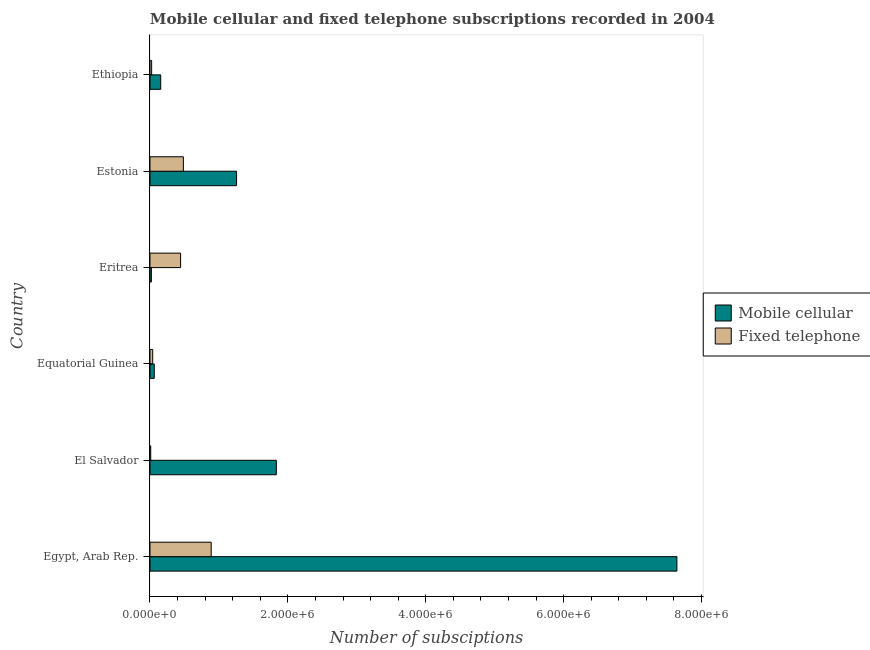How many different coloured bars are there?
Provide a succinct answer. 2. How many groups of bars are there?
Provide a short and direct response. 6. Are the number of bars per tick equal to the number of legend labels?
Ensure brevity in your answer.  Yes. Are the number of bars on each tick of the Y-axis equal?
Provide a succinct answer. Yes. How many bars are there on the 4th tick from the top?
Provide a succinct answer. 2. How many bars are there on the 6th tick from the bottom?
Keep it short and to the point. 2. What is the label of the 1st group of bars from the top?
Your response must be concise. Ethiopia. What is the number of mobile cellular subscriptions in Estonia?
Offer a very short reply. 1.26e+06. Across all countries, what is the maximum number of fixed telephone subscriptions?
Your answer should be compact. 8.88e+05. Across all countries, what is the minimum number of fixed telephone subscriptions?
Your answer should be very brief. 1.05e+04. In which country was the number of fixed telephone subscriptions maximum?
Your response must be concise. Egypt, Arab Rep. In which country was the number of mobile cellular subscriptions minimum?
Make the answer very short. Eritrea. What is the total number of fixed telephone subscriptions in the graph?
Make the answer very short. 1.89e+06. What is the difference between the number of fixed telephone subscriptions in Eritrea and that in Estonia?
Provide a succinct answer. -4.03e+04. What is the difference between the number of fixed telephone subscriptions in Estonia and the number of mobile cellular subscriptions in Egypt, Arab Rep.?
Give a very brief answer. -7.16e+06. What is the average number of mobile cellular subscriptions per country?
Offer a terse response. 1.83e+06. What is the difference between the number of fixed telephone subscriptions and number of mobile cellular subscriptions in Estonia?
Offer a very short reply. -7.71e+05. In how many countries, is the number of fixed telephone subscriptions greater than 5200000 ?
Your response must be concise. 0. What is the ratio of the number of mobile cellular subscriptions in Estonia to that in Ethiopia?
Your answer should be compact. 8.07. What is the difference between the highest and the second highest number of fixed telephone subscriptions?
Give a very brief answer. 4.03e+05. What is the difference between the highest and the lowest number of fixed telephone subscriptions?
Give a very brief answer. 8.77e+05. Is the sum of the number of fixed telephone subscriptions in El Salvador and Estonia greater than the maximum number of mobile cellular subscriptions across all countries?
Your response must be concise. No. What does the 2nd bar from the top in Ethiopia represents?
Provide a short and direct response. Mobile cellular. What does the 2nd bar from the bottom in Egypt, Arab Rep. represents?
Make the answer very short. Fixed telephone. How many bars are there?
Your answer should be very brief. 12. Are all the bars in the graph horizontal?
Keep it short and to the point. Yes. How many countries are there in the graph?
Give a very brief answer. 6. Where does the legend appear in the graph?
Your response must be concise. Center right. How many legend labels are there?
Your response must be concise. 2. What is the title of the graph?
Provide a short and direct response. Mobile cellular and fixed telephone subscriptions recorded in 2004. What is the label or title of the X-axis?
Make the answer very short. Number of subsciptions. What is the label or title of the Y-axis?
Provide a short and direct response. Country. What is the Number of subsciptions in Mobile cellular in Egypt, Arab Rep.?
Your answer should be compact. 7.64e+06. What is the Number of subsciptions of Fixed telephone in Egypt, Arab Rep.?
Make the answer very short. 8.88e+05. What is the Number of subsciptions of Mobile cellular in El Salvador?
Your response must be concise. 1.83e+06. What is the Number of subsciptions in Fixed telephone in El Salvador?
Offer a very short reply. 1.05e+04. What is the Number of subsciptions in Mobile cellular in Equatorial Guinea?
Ensure brevity in your answer.  6.19e+04. What is the Number of subsciptions in Fixed telephone in Equatorial Guinea?
Your answer should be compact. 3.93e+04. What is the Number of subsciptions in Fixed telephone in Eritrea?
Your answer should be very brief. 4.44e+05. What is the Number of subsciptions in Mobile cellular in Estonia?
Keep it short and to the point. 1.26e+06. What is the Number of subsciptions of Fixed telephone in Estonia?
Provide a short and direct response. 4.84e+05. What is the Number of subsciptions of Mobile cellular in Ethiopia?
Your answer should be compact. 1.56e+05. What is the Number of subsciptions of Fixed telephone in Ethiopia?
Provide a short and direct response. 2.40e+04. Across all countries, what is the maximum Number of subsciptions of Mobile cellular?
Provide a succinct answer. 7.64e+06. Across all countries, what is the maximum Number of subsciptions in Fixed telephone?
Your response must be concise. 8.88e+05. Across all countries, what is the minimum Number of subsciptions in Mobile cellular?
Give a very brief answer. 2.00e+04. Across all countries, what is the minimum Number of subsciptions in Fixed telephone?
Your answer should be compact. 1.05e+04. What is the total Number of subsciptions of Mobile cellular in the graph?
Make the answer very short. 1.10e+07. What is the total Number of subsciptions of Fixed telephone in the graph?
Give a very brief answer. 1.89e+06. What is the difference between the Number of subsciptions in Mobile cellular in Egypt, Arab Rep. and that in El Salvador?
Give a very brief answer. 5.81e+06. What is the difference between the Number of subsciptions in Fixed telephone in Egypt, Arab Rep. and that in El Salvador?
Offer a terse response. 8.77e+05. What is the difference between the Number of subsciptions of Mobile cellular in Egypt, Arab Rep. and that in Equatorial Guinea?
Your response must be concise. 7.58e+06. What is the difference between the Number of subsciptions of Fixed telephone in Egypt, Arab Rep. and that in Equatorial Guinea?
Ensure brevity in your answer.  8.49e+05. What is the difference between the Number of subsciptions in Mobile cellular in Egypt, Arab Rep. and that in Eritrea?
Keep it short and to the point. 7.62e+06. What is the difference between the Number of subsciptions in Fixed telephone in Egypt, Arab Rep. and that in Eritrea?
Provide a succinct answer. 4.44e+05. What is the difference between the Number of subsciptions in Mobile cellular in Egypt, Arab Rep. and that in Estonia?
Keep it short and to the point. 6.39e+06. What is the difference between the Number of subsciptions of Fixed telephone in Egypt, Arab Rep. and that in Estonia?
Your response must be concise. 4.03e+05. What is the difference between the Number of subsciptions in Mobile cellular in Egypt, Arab Rep. and that in Ethiopia?
Keep it short and to the point. 7.49e+06. What is the difference between the Number of subsciptions in Fixed telephone in Egypt, Arab Rep. and that in Ethiopia?
Provide a short and direct response. 8.64e+05. What is the difference between the Number of subsciptions of Mobile cellular in El Salvador and that in Equatorial Guinea?
Your answer should be very brief. 1.77e+06. What is the difference between the Number of subsciptions of Fixed telephone in El Salvador and that in Equatorial Guinea?
Make the answer very short. -2.88e+04. What is the difference between the Number of subsciptions of Mobile cellular in El Salvador and that in Eritrea?
Offer a terse response. 1.81e+06. What is the difference between the Number of subsciptions in Fixed telephone in El Salvador and that in Eritrea?
Your answer should be compact. -4.34e+05. What is the difference between the Number of subsciptions of Mobile cellular in El Salvador and that in Estonia?
Make the answer very short. 5.77e+05. What is the difference between the Number of subsciptions of Fixed telephone in El Salvador and that in Estonia?
Ensure brevity in your answer.  -4.74e+05. What is the difference between the Number of subsciptions of Mobile cellular in El Salvador and that in Ethiopia?
Give a very brief answer. 1.68e+06. What is the difference between the Number of subsciptions of Fixed telephone in El Salvador and that in Ethiopia?
Offer a terse response. -1.35e+04. What is the difference between the Number of subsciptions of Mobile cellular in Equatorial Guinea and that in Eritrea?
Your answer should be very brief. 4.19e+04. What is the difference between the Number of subsciptions of Fixed telephone in Equatorial Guinea and that in Eritrea?
Offer a terse response. -4.05e+05. What is the difference between the Number of subsciptions in Mobile cellular in Equatorial Guinea and that in Estonia?
Your answer should be very brief. -1.19e+06. What is the difference between the Number of subsciptions of Fixed telephone in Equatorial Guinea and that in Estonia?
Offer a terse response. -4.45e+05. What is the difference between the Number of subsciptions of Mobile cellular in Equatorial Guinea and that in Ethiopia?
Ensure brevity in your answer.  -9.36e+04. What is the difference between the Number of subsciptions of Fixed telephone in Equatorial Guinea and that in Ethiopia?
Provide a short and direct response. 1.53e+04. What is the difference between the Number of subsciptions in Mobile cellular in Eritrea and that in Estonia?
Your answer should be compact. -1.24e+06. What is the difference between the Number of subsciptions in Fixed telephone in Eritrea and that in Estonia?
Make the answer very short. -4.03e+04. What is the difference between the Number of subsciptions in Mobile cellular in Eritrea and that in Ethiopia?
Your answer should be compact. -1.36e+05. What is the difference between the Number of subsciptions of Fixed telephone in Eritrea and that in Ethiopia?
Your answer should be compact. 4.20e+05. What is the difference between the Number of subsciptions in Mobile cellular in Estonia and that in Ethiopia?
Give a very brief answer. 1.10e+06. What is the difference between the Number of subsciptions of Fixed telephone in Estonia and that in Ethiopia?
Your answer should be very brief. 4.60e+05. What is the difference between the Number of subsciptions in Mobile cellular in Egypt, Arab Rep. and the Number of subsciptions in Fixed telephone in El Salvador?
Keep it short and to the point. 7.63e+06. What is the difference between the Number of subsciptions of Mobile cellular in Egypt, Arab Rep. and the Number of subsciptions of Fixed telephone in Equatorial Guinea?
Provide a short and direct response. 7.60e+06. What is the difference between the Number of subsciptions in Mobile cellular in Egypt, Arab Rep. and the Number of subsciptions in Fixed telephone in Eritrea?
Offer a terse response. 7.20e+06. What is the difference between the Number of subsciptions of Mobile cellular in Egypt, Arab Rep. and the Number of subsciptions of Fixed telephone in Estonia?
Your answer should be very brief. 7.16e+06. What is the difference between the Number of subsciptions of Mobile cellular in Egypt, Arab Rep. and the Number of subsciptions of Fixed telephone in Ethiopia?
Provide a short and direct response. 7.62e+06. What is the difference between the Number of subsciptions of Mobile cellular in El Salvador and the Number of subsciptions of Fixed telephone in Equatorial Guinea?
Keep it short and to the point. 1.79e+06. What is the difference between the Number of subsciptions in Mobile cellular in El Salvador and the Number of subsciptions in Fixed telephone in Eritrea?
Your answer should be very brief. 1.39e+06. What is the difference between the Number of subsciptions in Mobile cellular in El Salvador and the Number of subsciptions in Fixed telephone in Estonia?
Offer a very short reply. 1.35e+06. What is the difference between the Number of subsciptions in Mobile cellular in El Salvador and the Number of subsciptions in Fixed telephone in Ethiopia?
Your answer should be compact. 1.81e+06. What is the difference between the Number of subsciptions in Mobile cellular in Equatorial Guinea and the Number of subsciptions in Fixed telephone in Eritrea?
Provide a short and direct response. -3.82e+05. What is the difference between the Number of subsciptions in Mobile cellular in Equatorial Guinea and the Number of subsciptions in Fixed telephone in Estonia?
Your answer should be very brief. -4.22e+05. What is the difference between the Number of subsciptions in Mobile cellular in Equatorial Guinea and the Number of subsciptions in Fixed telephone in Ethiopia?
Keep it short and to the point. 3.79e+04. What is the difference between the Number of subsciptions of Mobile cellular in Eritrea and the Number of subsciptions of Fixed telephone in Estonia?
Your answer should be very brief. -4.64e+05. What is the difference between the Number of subsciptions in Mobile cellular in Eritrea and the Number of subsciptions in Fixed telephone in Ethiopia?
Give a very brief answer. -3958. What is the difference between the Number of subsciptions of Mobile cellular in Estonia and the Number of subsciptions of Fixed telephone in Ethiopia?
Your answer should be compact. 1.23e+06. What is the average Number of subsciptions of Mobile cellular per country?
Your answer should be very brief. 1.83e+06. What is the average Number of subsciptions of Fixed telephone per country?
Your answer should be compact. 3.15e+05. What is the difference between the Number of subsciptions in Mobile cellular and Number of subsciptions in Fixed telephone in Egypt, Arab Rep.?
Your answer should be compact. 6.76e+06. What is the difference between the Number of subsciptions in Mobile cellular and Number of subsciptions in Fixed telephone in El Salvador?
Your answer should be very brief. 1.82e+06. What is the difference between the Number of subsciptions in Mobile cellular and Number of subsciptions in Fixed telephone in Equatorial Guinea?
Ensure brevity in your answer.  2.26e+04. What is the difference between the Number of subsciptions of Mobile cellular and Number of subsciptions of Fixed telephone in Eritrea?
Offer a terse response. -4.24e+05. What is the difference between the Number of subsciptions in Mobile cellular and Number of subsciptions in Fixed telephone in Estonia?
Provide a short and direct response. 7.71e+05. What is the difference between the Number of subsciptions in Mobile cellular and Number of subsciptions in Fixed telephone in Ethiopia?
Offer a very short reply. 1.32e+05. What is the ratio of the Number of subsciptions of Mobile cellular in Egypt, Arab Rep. to that in El Salvador?
Give a very brief answer. 4.17. What is the ratio of the Number of subsciptions in Fixed telephone in Egypt, Arab Rep. to that in El Salvador?
Your answer should be very brief. 84.55. What is the ratio of the Number of subsciptions in Mobile cellular in Egypt, Arab Rep. to that in Equatorial Guinea?
Offer a terse response. 123.47. What is the ratio of the Number of subsciptions in Fixed telephone in Egypt, Arab Rep. to that in Equatorial Guinea?
Keep it short and to the point. 22.61. What is the ratio of the Number of subsciptions of Mobile cellular in Egypt, Arab Rep. to that in Eritrea?
Keep it short and to the point. 382.15. What is the ratio of the Number of subsciptions of Fixed telephone in Egypt, Arab Rep. to that in Eritrea?
Make the answer very short. 2. What is the ratio of the Number of subsciptions of Mobile cellular in Egypt, Arab Rep. to that in Estonia?
Ensure brevity in your answer.  6.09. What is the ratio of the Number of subsciptions of Fixed telephone in Egypt, Arab Rep. to that in Estonia?
Provide a succinct answer. 1.83. What is the ratio of the Number of subsciptions in Mobile cellular in Egypt, Arab Rep. to that in Ethiopia?
Your answer should be compact. 49.14. What is the ratio of the Number of subsciptions of Fixed telephone in Egypt, Arab Rep. to that in Ethiopia?
Your answer should be very brief. 37.06. What is the ratio of the Number of subsciptions in Mobile cellular in El Salvador to that in Equatorial Guinea?
Provide a succinct answer. 29.61. What is the ratio of the Number of subsciptions of Fixed telephone in El Salvador to that in Equatorial Guinea?
Make the answer very short. 0.27. What is the ratio of the Number of subsciptions of Mobile cellular in El Salvador to that in Eritrea?
Your answer should be very brief. 91.63. What is the ratio of the Number of subsciptions of Fixed telephone in El Salvador to that in Eritrea?
Provide a short and direct response. 0.02. What is the ratio of the Number of subsciptions of Mobile cellular in El Salvador to that in Estonia?
Give a very brief answer. 1.46. What is the ratio of the Number of subsciptions in Fixed telephone in El Salvador to that in Estonia?
Provide a short and direct response. 0.02. What is the ratio of the Number of subsciptions of Mobile cellular in El Salvador to that in Ethiopia?
Offer a very short reply. 11.78. What is the ratio of the Number of subsciptions in Fixed telephone in El Salvador to that in Ethiopia?
Offer a very short reply. 0.44. What is the ratio of the Number of subsciptions in Mobile cellular in Equatorial Guinea to that in Eritrea?
Make the answer very short. 3.1. What is the ratio of the Number of subsciptions of Fixed telephone in Equatorial Guinea to that in Eritrea?
Provide a short and direct response. 0.09. What is the ratio of the Number of subsciptions in Mobile cellular in Equatorial Guinea to that in Estonia?
Your answer should be very brief. 0.05. What is the ratio of the Number of subsciptions in Fixed telephone in Equatorial Guinea to that in Estonia?
Ensure brevity in your answer.  0.08. What is the ratio of the Number of subsciptions of Mobile cellular in Equatorial Guinea to that in Ethiopia?
Make the answer very short. 0.4. What is the ratio of the Number of subsciptions of Fixed telephone in Equatorial Guinea to that in Ethiopia?
Your response must be concise. 1.64. What is the ratio of the Number of subsciptions of Mobile cellular in Eritrea to that in Estonia?
Your answer should be very brief. 0.02. What is the ratio of the Number of subsciptions in Mobile cellular in Eritrea to that in Ethiopia?
Provide a short and direct response. 0.13. What is the ratio of the Number of subsciptions of Fixed telephone in Eritrea to that in Ethiopia?
Keep it short and to the point. 18.53. What is the ratio of the Number of subsciptions of Mobile cellular in Estonia to that in Ethiopia?
Offer a terse response. 8.07. What is the ratio of the Number of subsciptions of Fixed telephone in Estonia to that in Ethiopia?
Offer a terse response. 20.22. What is the difference between the highest and the second highest Number of subsciptions in Mobile cellular?
Offer a terse response. 5.81e+06. What is the difference between the highest and the second highest Number of subsciptions of Fixed telephone?
Ensure brevity in your answer.  4.03e+05. What is the difference between the highest and the lowest Number of subsciptions in Mobile cellular?
Offer a very short reply. 7.62e+06. What is the difference between the highest and the lowest Number of subsciptions in Fixed telephone?
Provide a short and direct response. 8.77e+05. 